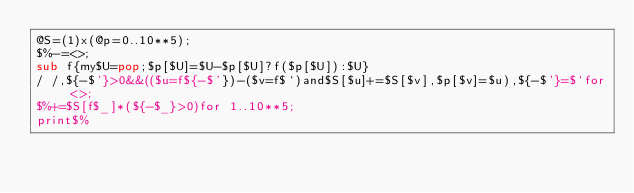Convert code to text. <code><loc_0><loc_0><loc_500><loc_500><_Perl_>@S=(1)x(@p=0..10**5);
$%-=<>;
sub f{my$U=pop;$p[$U]=$U-$p[$U]?f($p[$U]):$U}
/ /,${-$'}>0&&(($u=f${-$'})-($v=f$`)and$S[$u]+=$S[$v],$p[$v]=$u),${-$'}=$`for<>;
$%+=$S[f$_]*(${-$_}>0)for 1..10**5;
print$%</code> 